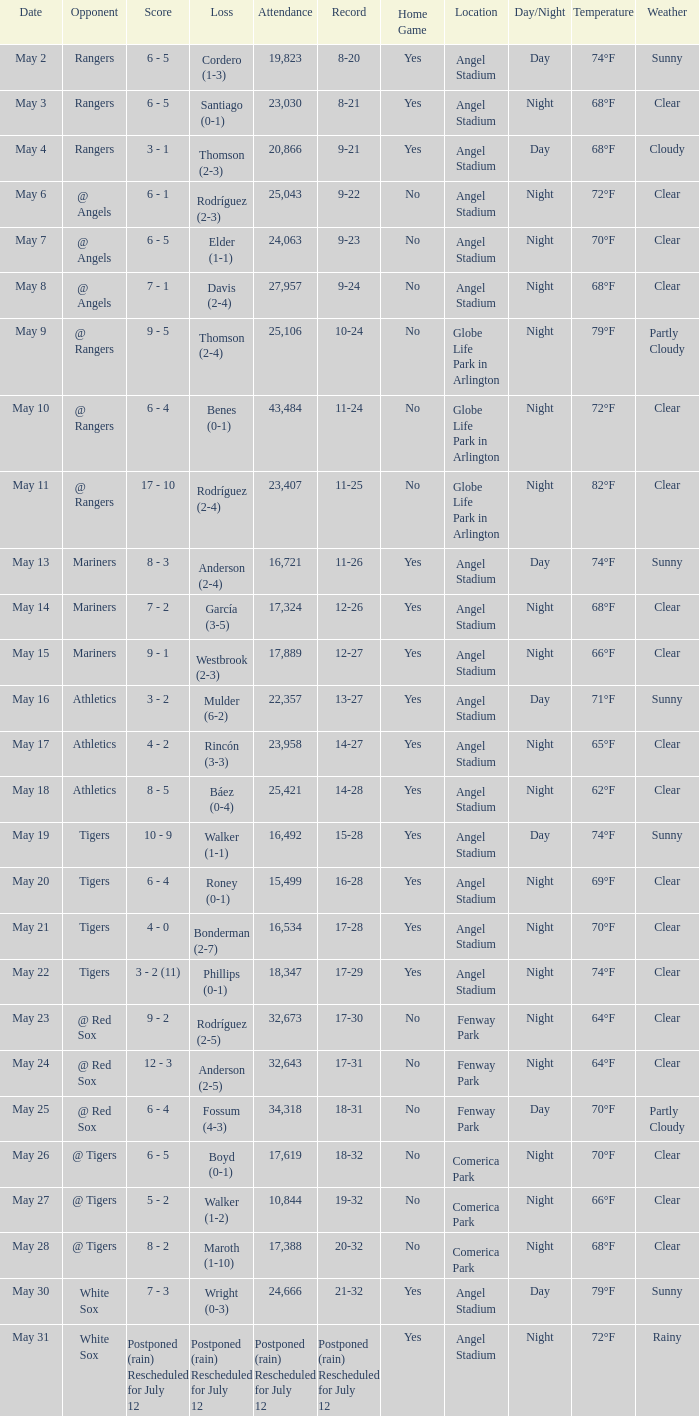What date did the Indians have a record of 14-28? May 18. 